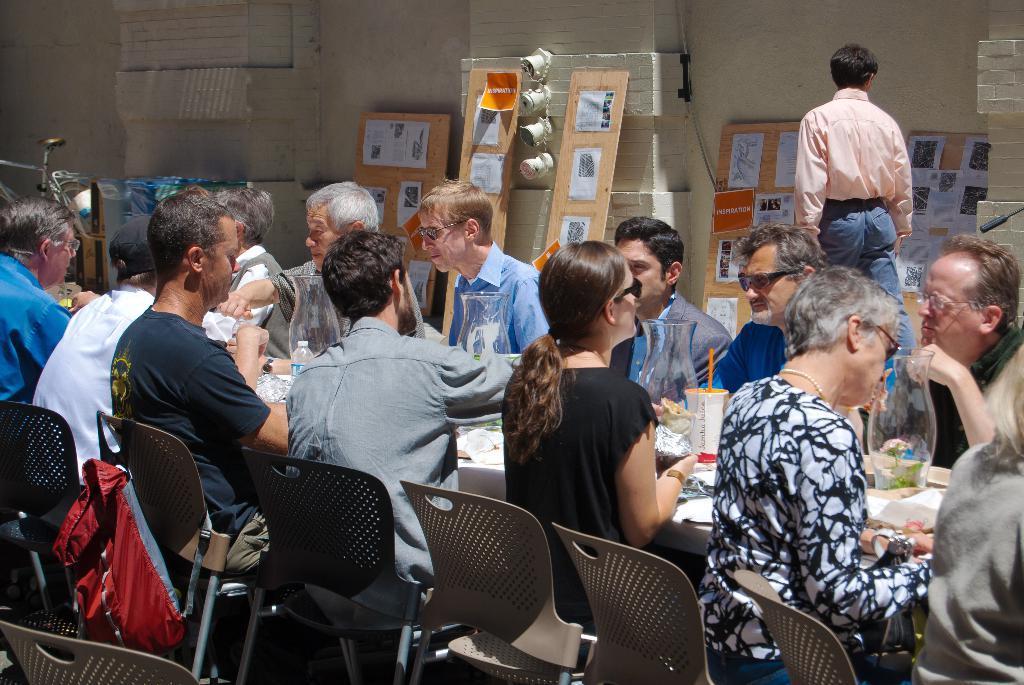In one or two sentences, can you explain what this image depicts? In this image I can see group of people sitting on chair, in front I can see few food items, bottles, glasses on the table, at the back I can see the person walking wearing peach color shirt, blue pant. I can also see few boards, and wall is in cream color. 